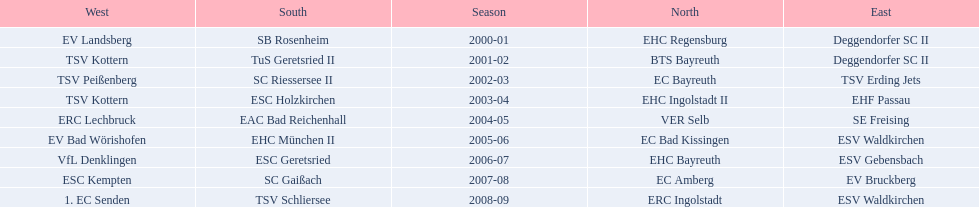Which teams won the north in their respective years? 2000-01, EHC Regensburg, BTS Bayreuth, EC Bayreuth, EHC Ingolstadt II, VER Selb, EC Bad Kissingen, EHC Bayreuth, EC Amberg, ERC Ingolstadt. Which one only won in 2000-01? EHC Regensburg. 